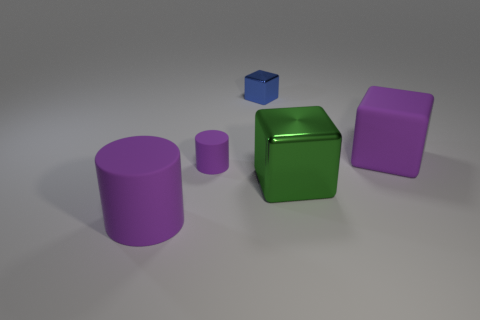Subtract all large metallic cubes. How many cubes are left? 2 Add 2 small brown rubber balls. How many objects exist? 7 Add 4 big matte cylinders. How many big matte cylinders exist? 5 Subtract 0 green spheres. How many objects are left? 5 Subtract all cylinders. How many objects are left? 3 Subtract 1 cylinders. How many cylinders are left? 1 Subtract all yellow blocks. Subtract all brown cylinders. How many blocks are left? 3 Subtract all brown cylinders. How many yellow cubes are left? 0 Subtract all big brown rubber cylinders. Subtract all tiny blue metallic things. How many objects are left? 4 Add 2 tiny purple rubber objects. How many tiny purple rubber objects are left? 3 